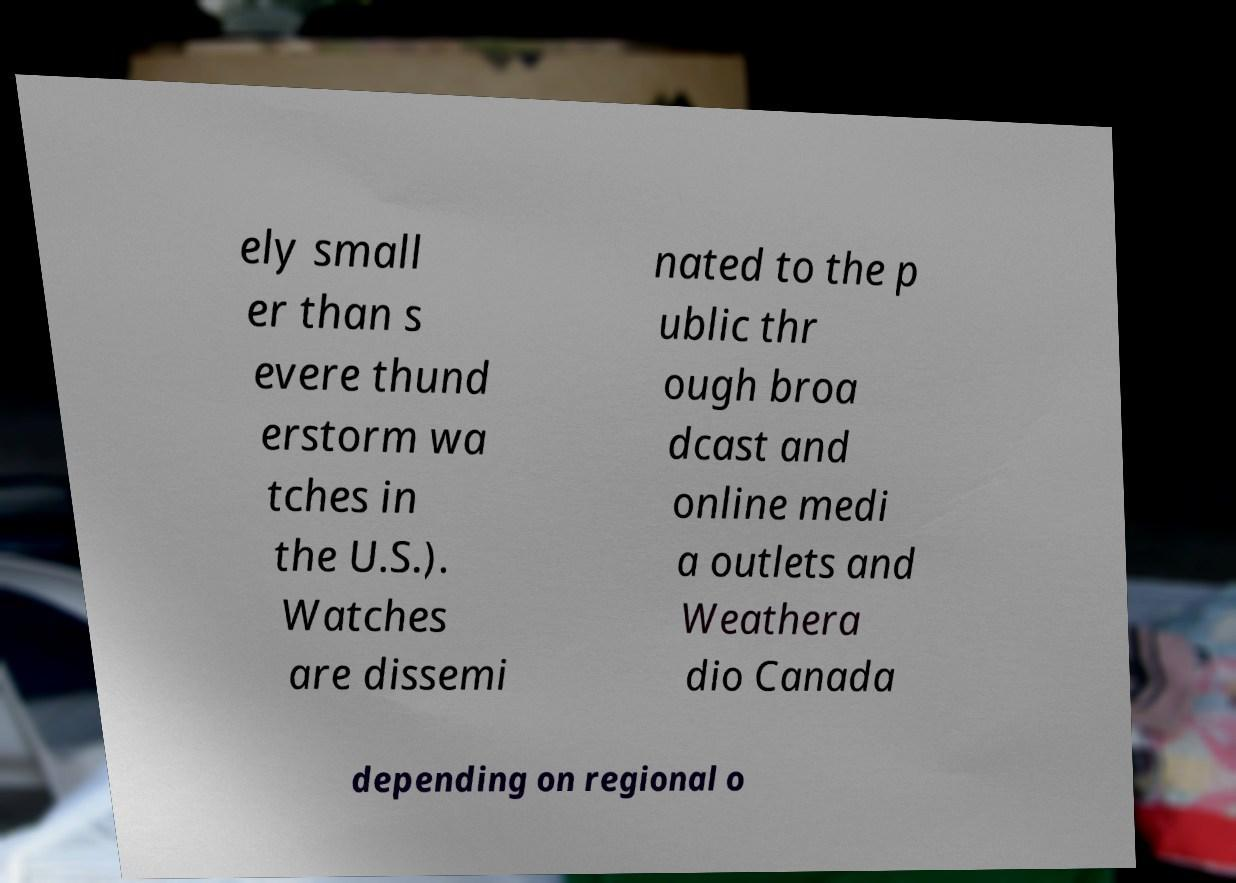What messages or text are displayed in this image? I need them in a readable, typed format. ely small er than s evere thund erstorm wa tches in the U.S.). Watches are dissemi nated to the p ublic thr ough broa dcast and online medi a outlets and Weathera dio Canada depending on regional o 